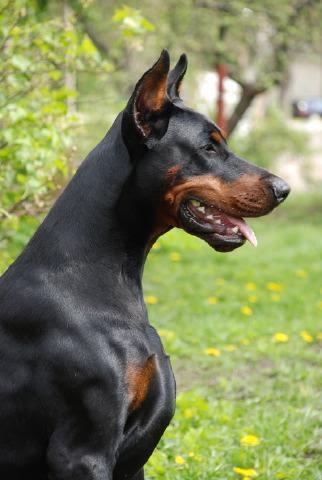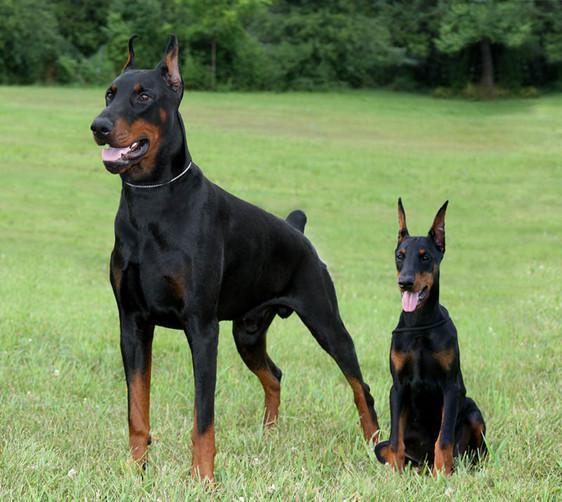The first image is the image on the left, the second image is the image on the right. Assess this claim about the two images: "At least one doberman has its tongue out.". Correct or not? Answer yes or no. Yes. The first image is the image on the left, the second image is the image on the right. For the images displayed, is the sentence "In one image, there are two dogs facing each other." factually correct? Answer yes or no. No. 